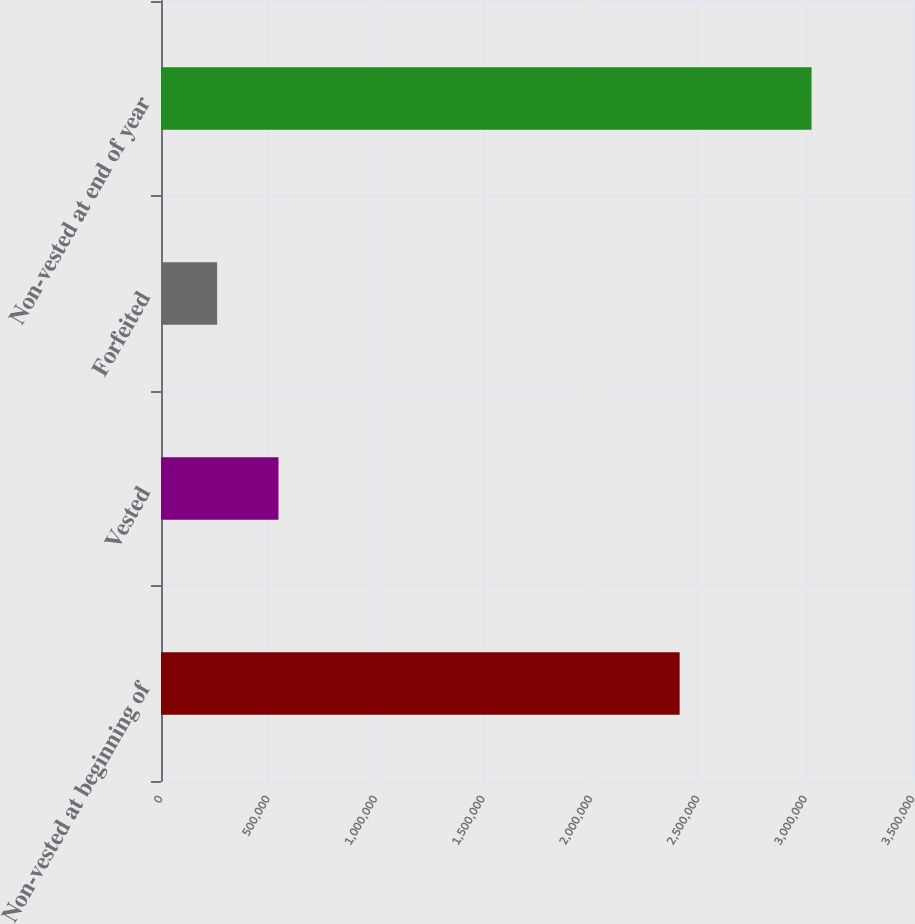Convert chart. <chart><loc_0><loc_0><loc_500><loc_500><bar_chart><fcel>Non-vested at beginning of<fcel>Vested<fcel>Forfeited<fcel>Non-vested at end of year<nl><fcel>2.41387e+06<fcel>546741<fcel>261168<fcel>3.02788e+06<nl></chart> 